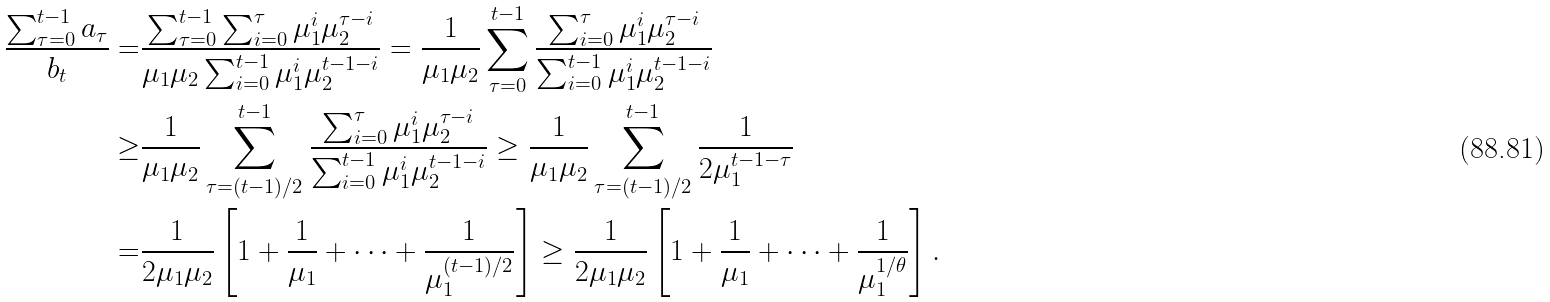Convert formula to latex. <formula><loc_0><loc_0><loc_500><loc_500>\frac { \sum _ { \tau = 0 } ^ { t - 1 } a _ { \tau } } { b _ { t } } = & \frac { \sum _ { \tau = 0 } ^ { t - 1 } \sum _ { i = 0 } ^ { \tau } \mu _ { 1 } ^ { i } \mu _ { 2 } ^ { \tau - i } } { \mu _ { 1 } \mu _ { 2 } \sum _ { i = 0 } ^ { t - 1 } \mu _ { 1 } ^ { i } \mu _ { 2 } ^ { t - 1 - i } } = \frac { 1 } { \mu _ { 1 } \mu _ { 2 } } \sum _ { \tau = 0 } ^ { t - 1 } \frac { \sum _ { i = 0 } ^ { \tau } \mu _ { 1 } ^ { i } \mu _ { 2 } ^ { \tau - i } } { \sum _ { i = 0 } ^ { t - 1 } \mu _ { 1 } ^ { i } \mu _ { 2 } ^ { t - 1 - i } } \\ \geq & \frac { 1 } { \mu _ { 1 } \mu _ { 2 } } \sum _ { \tau = ( t - 1 ) / 2 } ^ { t - 1 } \frac { \sum _ { i = 0 } ^ { \tau } \mu _ { 1 } ^ { i } \mu _ { 2 } ^ { \tau - i } } { \sum _ { i = 0 } ^ { t - 1 } \mu _ { 1 } ^ { i } \mu _ { 2 } ^ { t - 1 - i } } \geq \frac { 1 } { \mu _ { 1 } \mu _ { 2 } } \sum _ { \tau = ( t - 1 ) / 2 } ^ { t - 1 } \frac { 1 } { 2 \mu _ { 1 } ^ { t - 1 - \tau } } \\ = & \frac { 1 } { 2 \mu _ { 1 } \mu _ { 2 } } \left [ 1 + \frac { 1 } { \mu _ { 1 } } + \cdots + \frac { 1 } { \mu _ { 1 } ^ { ( t - 1 ) / 2 } } \right ] \geq \frac { 1 } { 2 \mu _ { 1 } \mu _ { 2 } } \left [ 1 + \frac { 1 } { \mu _ { 1 } } + \cdots + \frac { 1 } { \mu _ { 1 } ^ { 1 / \theta } } \right ] .</formula> 